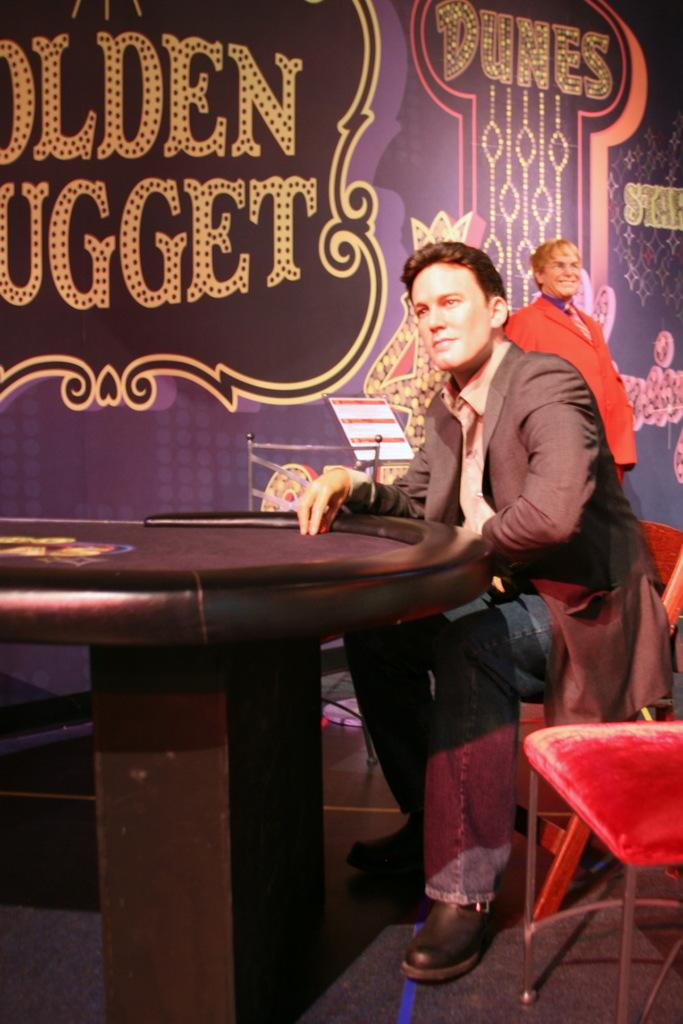What is the person in the image wearing? The person is wearing a red color blazer in the image. What is the person standing near? The person is standing near a board. What is the position of the man in the image? The man is sitting on a chair in the image. What is the man in front of? The man is in front of a table. What type of surface is visible in the image? The image shows a floor. What type of bone can be seen in the image? There is no bone present in the image. Is there a monkey sitting on the table in the image? No, there is no monkey present in the image; it only shows a man sitting on a chair in front of a table. 